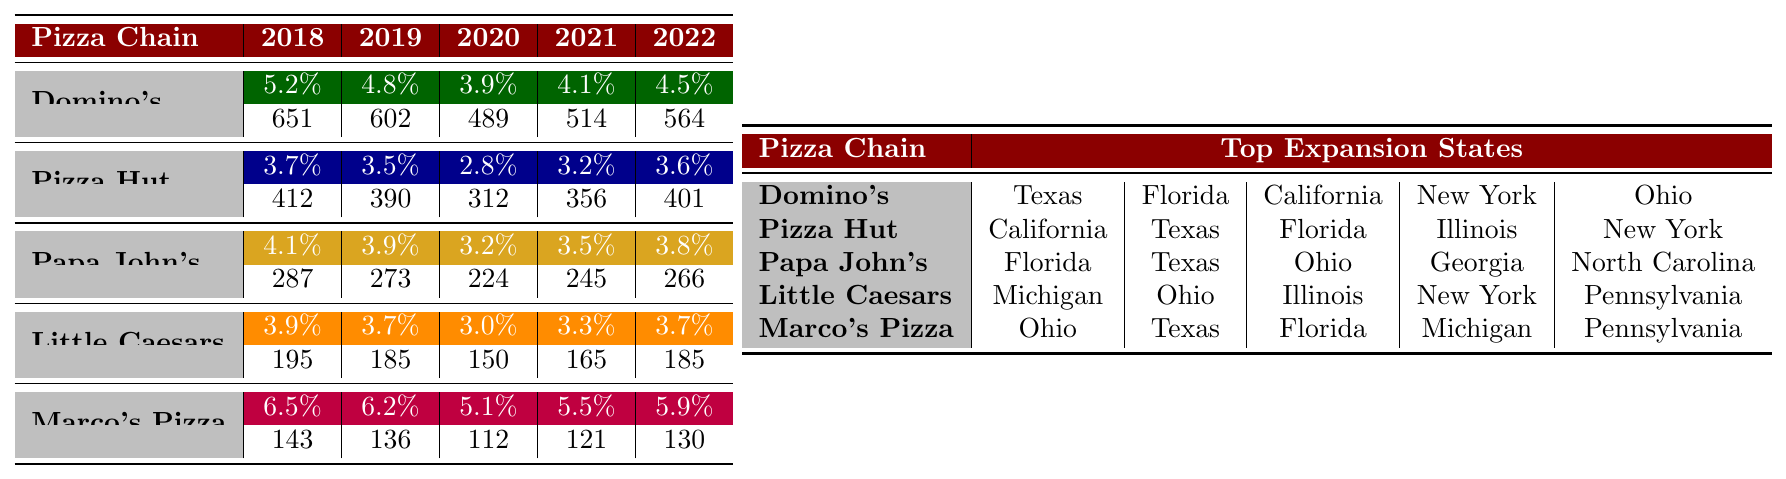What was the expansion rate of Marco's Pizza in 2020? According to the table, the expansion rate for Marco's Pizza in 2020 is 5.1%.
Answer: 5.1% Which pizza chain had the highest expansion rate in 2019? In 2019, Marco's Pizza had the highest expansion rate at 6.2%.
Answer: Marco's Pizza What is the total number of new locations for Domino's over the five years? To find the total, add the new locations: 651 + 602 + 489 + 514 + 564 = 2820.
Answer: 2820 In which year did Little Caesars have the lowest expansion rate? By examining the table, Little Caesars had the lowest expansion rate of 3.0% in 2020.
Answer: 2020 Did Pizza Hut expand more locations than Papa John's in 2021? Yes, Pizza Hut added 356 locations while Papa John's expanded only 245 locations in 2021.
Answer: Yes What is the average expansion rate for Pizza Hut over the five years? The average expansion rate for Pizza Hut is calculated as follows: (3.7 + 3.5 + 2.8 + 3.2 + 3.6) / 5 = 3.36%.
Answer: 3.36% What is the difference in the number of new locations between Domino's and Marco's Pizza in 2022? Domino's had 564 new locations, and Marco's Pizza had 130. The difference is 564 - 130 = 434.
Answer: 434 Which pizza chain had the highest number of new locations in 2018? Looking at the table, Domino's had the highest number of new locations in 2018 with 651.
Answer: Domino's Which state was a top expansion state for both Domino's and Papa John's? Florida was a top expansion state for both Domino's and Papa John's according to the table.
Answer: Florida What is the trend of expansion rates for Little Caesars from 2018 to 2022? The expansion rates for Little Caesars are decreasing from 3.9% in 2018 to 3.7% in 2019, 3.0% in 2020, 3.3% in 2021, and then back up to 3.7% in 2022, indicating fluctuation with a decrease overall.
Answer: Fluctuating trend with a general decrease 